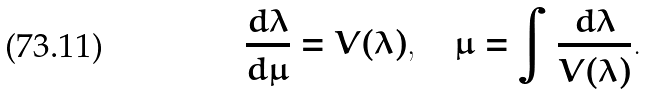Convert formula to latex. <formula><loc_0><loc_0><loc_500><loc_500>\frac { d \lambda } { d \mu } = V ( \lambda ) , \quad \mu = \int \frac { d \lambda } { V ( \lambda ) } .</formula> 